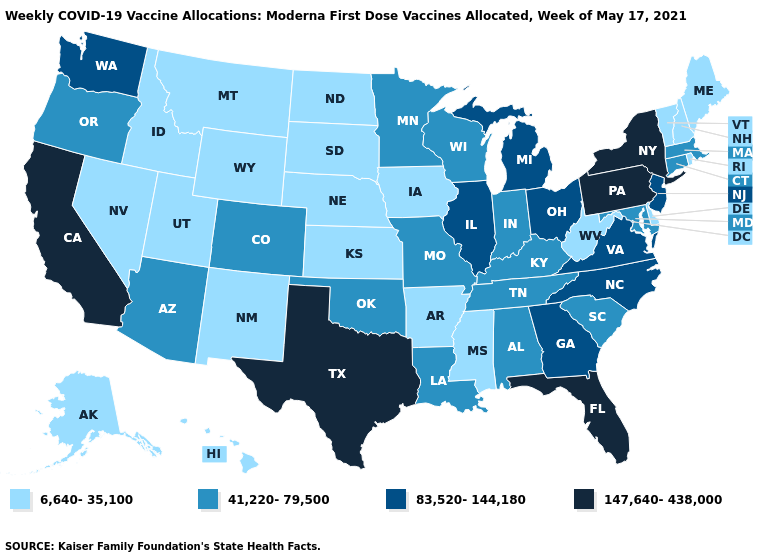Does the map have missing data?
Be succinct. No. How many symbols are there in the legend?
Short answer required. 4. What is the highest value in the West ?
Short answer required. 147,640-438,000. Does New Hampshire have the lowest value in the Northeast?
Answer briefly. Yes. Which states have the lowest value in the USA?
Answer briefly. Alaska, Arkansas, Delaware, Hawaii, Idaho, Iowa, Kansas, Maine, Mississippi, Montana, Nebraska, Nevada, New Hampshire, New Mexico, North Dakota, Rhode Island, South Dakota, Utah, Vermont, West Virginia, Wyoming. What is the value of Virginia?
Short answer required. 83,520-144,180. Name the states that have a value in the range 147,640-438,000?
Quick response, please. California, Florida, New York, Pennsylvania, Texas. What is the value of Illinois?
Write a very short answer. 83,520-144,180. Name the states that have a value in the range 6,640-35,100?
Be succinct. Alaska, Arkansas, Delaware, Hawaii, Idaho, Iowa, Kansas, Maine, Mississippi, Montana, Nebraska, Nevada, New Hampshire, New Mexico, North Dakota, Rhode Island, South Dakota, Utah, Vermont, West Virginia, Wyoming. What is the value of New Hampshire?
Give a very brief answer. 6,640-35,100. Name the states that have a value in the range 41,220-79,500?
Keep it brief. Alabama, Arizona, Colorado, Connecticut, Indiana, Kentucky, Louisiana, Maryland, Massachusetts, Minnesota, Missouri, Oklahoma, Oregon, South Carolina, Tennessee, Wisconsin. Does Idaho have the highest value in the USA?
Give a very brief answer. No. Does the first symbol in the legend represent the smallest category?
Concise answer only. Yes. Does Colorado have the lowest value in the USA?
Answer briefly. No. 